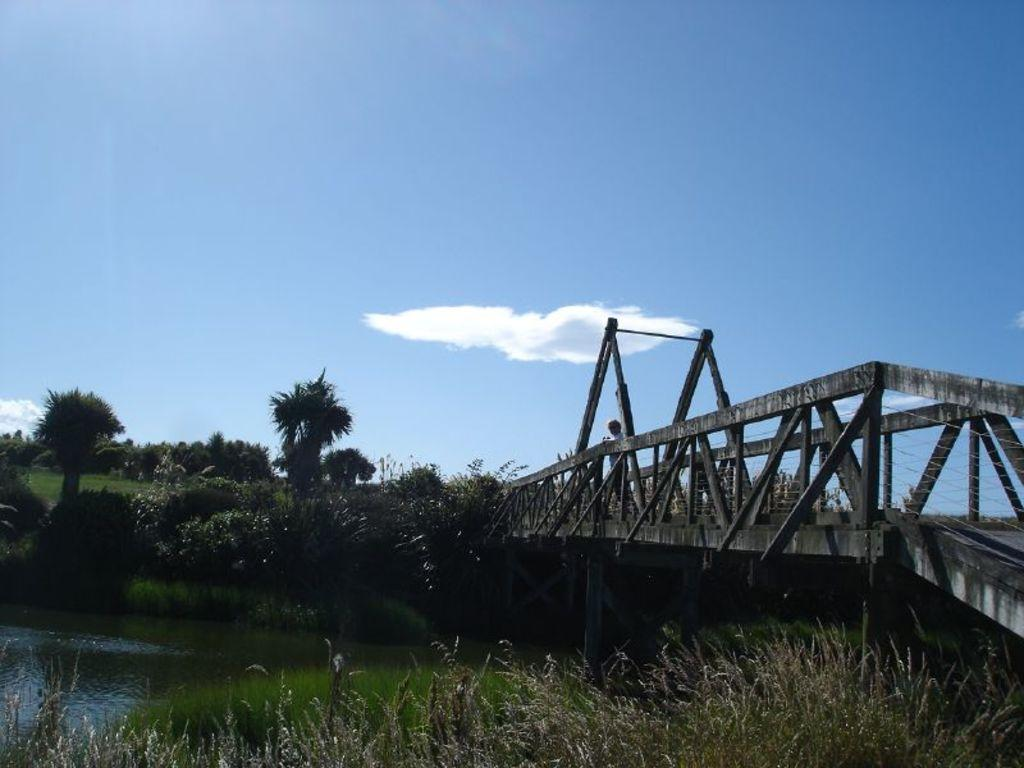What type of living organisms can be seen in the image? Plants and trees are visible in the image. What is the primary element present in the image? Water is visible in the image. What structure can be seen in the image? There is a bridge in the image. Can you describe the person in the image? A person is standing on the bridge. What is visible in the background of the image? The sky is visible in the background of the image, and clouds are present. What type of store is being celebrated on the person's birthday in the image? There is no store or birthday celebration present in the image. What action is the person performing on the bridge in the image? The image does not show the person performing any specific action on the bridge. 